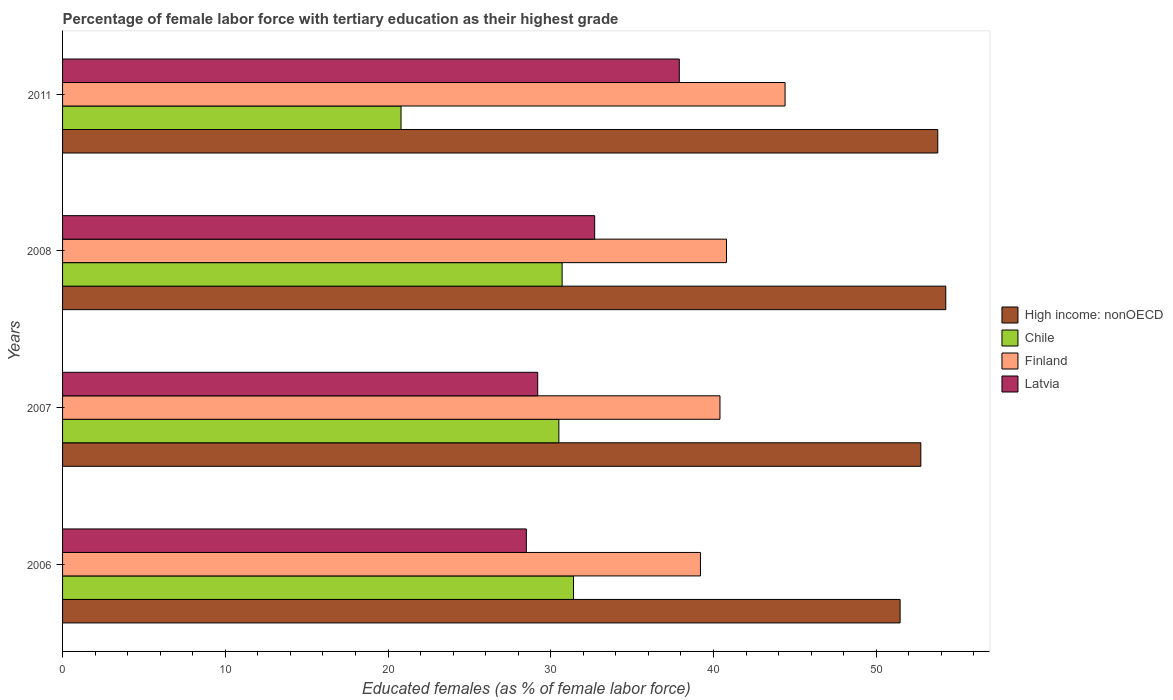Are the number of bars on each tick of the Y-axis equal?
Your answer should be compact. Yes. What is the percentage of female labor force with tertiary education in Latvia in 2008?
Your response must be concise. 32.7. Across all years, what is the maximum percentage of female labor force with tertiary education in High income: nonOECD?
Provide a short and direct response. 54.28. In which year was the percentage of female labor force with tertiary education in Finland minimum?
Ensure brevity in your answer.  2006. What is the total percentage of female labor force with tertiary education in High income: nonOECD in the graph?
Your answer should be very brief. 212.27. What is the difference between the percentage of female labor force with tertiary education in Chile in 2006 and that in 2008?
Offer a very short reply. 0.7. What is the difference between the percentage of female labor force with tertiary education in Latvia in 2006 and the percentage of female labor force with tertiary education in Finland in 2011?
Keep it short and to the point. -15.9. What is the average percentage of female labor force with tertiary education in High income: nonOECD per year?
Your response must be concise. 53.07. In the year 2008, what is the difference between the percentage of female labor force with tertiary education in High income: nonOECD and percentage of female labor force with tertiary education in Finland?
Offer a terse response. 13.48. In how many years, is the percentage of female labor force with tertiary education in Finland greater than 42 %?
Give a very brief answer. 1. What is the ratio of the percentage of female labor force with tertiary education in Finland in 2006 to that in 2008?
Your answer should be compact. 0.96. What is the difference between the highest and the second highest percentage of female labor force with tertiary education in High income: nonOECD?
Your answer should be very brief. 0.49. What is the difference between the highest and the lowest percentage of female labor force with tertiary education in Chile?
Offer a terse response. 10.6. In how many years, is the percentage of female labor force with tertiary education in Chile greater than the average percentage of female labor force with tertiary education in Chile taken over all years?
Give a very brief answer. 3. Is the sum of the percentage of female labor force with tertiary education in Latvia in 2007 and 2008 greater than the maximum percentage of female labor force with tertiary education in Chile across all years?
Provide a short and direct response. Yes. Is it the case that in every year, the sum of the percentage of female labor force with tertiary education in Chile and percentage of female labor force with tertiary education in Finland is greater than the sum of percentage of female labor force with tertiary education in High income: nonOECD and percentage of female labor force with tertiary education in Latvia?
Offer a very short reply. No. What does the 4th bar from the top in 2006 represents?
Make the answer very short. High income: nonOECD. What does the 3rd bar from the bottom in 2007 represents?
Your response must be concise. Finland. Are all the bars in the graph horizontal?
Ensure brevity in your answer.  Yes. Does the graph contain any zero values?
Provide a short and direct response. No. How many legend labels are there?
Your response must be concise. 4. What is the title of the graph?
Your response must be concise. Percentage of female labor force with tertiary education as their highest grade. Does "Madagascar" appear as one of the legend labels in the graph?
Your response must be concise. No. What is the label or title of the X-axis?
Ensure brevity in your answer.  Educated females (as % of female labor force). What is the Educated females (as % of female labor force) in High income: nonOECD in 2006?
Make the answer very short. 51.47. What is the Educated females (as % of female labor force) of Chile in 2006?
Your response must be concise. 31.4. What is the Educated females (as % of female labor force) of Finland in 2006?
Your response must be concise. 39.2. What is the Educated females (as % of female labor force) of High income: nonOECD in 2007?
Provide a short and direct response. 52.74. What is the Educated females (as % of female labor force) in Chile in 2007?
Ensure brevity in your answer.  30.5. What is the Educated females (as % of female labor force) in Finland in 2007?
Your response must be concise. 40.4. What is the Educated females (as % of female labor force) in Latvia in 2007?
Provide a succinct answer. 29.2. What is the Educated females (as % of female labor force) in High income: nonOECD in 2008?
Offer a very short reply. 54.28. What is the Educated females (as % of female labor force) of Chile in 2008?
Give a very brief answer. 30.7. What is the Educated females (as % of female labor force) in Finland in 2008?
Provide a succinct answer. 40.8. What is the Educated females (as % of female labor force) of Latvia in 2008?
Make the answer very short. 32.7. What is the Educated females (as % of female labor force) in High income: nonOECD in 2011?
Give a very brief answer. 53.78. What is the Educated females (as % of female labor force) in Chile in 2011?
Provide a succinct answer. 20.8. What is the Educated females (as % of female labor force) in Finland in 2011?
Offer a terse response. 44.4. What is the Educated females (as % of female labor force) in Latvia in 2011?
Make the answer very short. 37.9. Across all years, what is the maximum Educated females (as % of female labor force) of High income: nonOECD?
Your answer should be compact. 54.28. Across all years, what is the maximum Educated females (as % of female labor force) of Chile?
Your answer should be very brief. 31.4. Across all years, what is the maximum Educated females (as % of female labor force) of Finland?
Keep it short and to the point. 44.4. Across all years, what is the maximum Educated females (as % of female labor force) in Latvia?
Your answer should be compact. 37.9. Across all years, what is the minimum Educated females (as % of female labor force) in High income: nonOECD?
Keep it short and to the point. 51.47. Across all years, what is the minimum Educated females (as % of female labor force) in Chile?
Your response must be concise. 20.8. Across all years, what is the minimum Educated females (as % of female labor force) of Finland?
Ensure brevity in your answer.  39.2. What is the total Educated females (as % of female labor force) of High income: nonOECD in the graph?
Your response must be concise. 212.27. What is the total Educated females (as % of female labor force) in Chile in the graph?
Ensure brevity in your answer.  113.4. What is the total Educated females (as % of female labor force) of Finland in the graph?
Provide a succinct answer. 164.8. What is the total Educated females (as % of female labor force) of Latvia in the graph?
Give a very brief answer. 128.3. What is the difference between the Educated females (as % of female labor force) of High income: nonOECD in 2006 and that in 2007?
Provide a succinct answer. -1.27. What is the difference between the Educated females (as % of female labor force) in Chile in 2006 and that in 2007?
Provide a short and direct response. 0.9. What is the difference between the Educated females (as % of female labor force) of Finland in 2006 and that in 2007?
Give a very brief answer. -1.2. What is the difference between the Educated females (as % of female labor force) in High income: nonOECD in 2006 and that in 2008?
Offer a terse response. -2.81. What is the difference between the Educated females (as % of female labor force) of Chile in 2006 and that in 2008?
Provide a short and direct response. 0.7. What is the difference between the Educated females (as % of female labor force) in Latvia in 2006 and that in 2008?
Offer a very short reply. -4.2. What is the difference between the Educated females (as % of female labor force) of High income: nonOECD in 2006 and that in 2011?
Give a very brief answer. -2.31. What is the difference between the Educated females (as % of female labor force) in Chile in 2006 and that in 2011?
Your answer should be very brief. 10.6. What is the difference between the Educated females (as % of female labor force) in Latvia in 2006 and that in 2011?
Provide a succinct answer. -9.4. What is the difference between the Educated females (as % of female labor force) of High income: nonOECD in 2007 and that in 2008?
Your answer should be very brief. -1.53. What is the difference between the Educated females (as % of female labor force) of Chile in 2007 and that in 2008?
Keep it short and to the point. -0.2. What is the difference between the Educated females (as % of female labor force) of Finland in 2007 and that in 2008?
Keep it short and to the point. -0.4. What is the difference between the Educated females (as % of female labor force) of Latvia in 2007 and that in 2008?
Ensure brevity in your answer.  -3.5. What is the difference between the Educated females (as % of female labor force) of High income: nonOECD in 2007 and that in 2011?
Your response must be concise. -1.04. What is the difference between the Educated females (as % of female labor force) in Latvia in 2007 and that in 2011?
Provide a succinct answer. -8.7. What is the difference between the Educated females (as % of female labor force) of High income: nonOECD in 2008 and that in 2011?
Offer a very short reply. 0.49. What is the difference between the Educated females (as % of female labor force) of Chile in 2008 and that in 2011?
Your answer should be very brief. 9.9. What is the difference between the Educated females (as % of female labor force) in Finland in 2008 and that in 2011?
Provide a succinct answer. -3.6. What is the difference between the Educated females (as % of female labor force) in High income: nonOECD in 2006 and the Educated females (as % of female labor force) in Chile in 2007?
Provide a short and direct response. 20.97. What is the difference between the Educated females (as % of female labor force) of High income: nonOECD in 2006 and the Educated females (as % of female labor force) of Finland in 2007?
Provide a succinct answer. 11.07. What is the difference between the Educated females (as % of female labor force) of High income: nonOECD in 2006 and the Educated females (as % of female labor force) of Latvia in 2007?
Offer a very short reply. 22.27. What is the difference between the Educated females (as % of female labor force) in Chile in 2006 and the Educated females (as % of female labor force) in Finland in 2007?
Ensure brevity in your answer.  -9. What is the difference between the Educated females (as % of female labor force) of Chile in 2006 and the Educated females (as % of female labor force) of Latvia in 2007?
Your answer should be very brief. 2.2. What is the difference between the Educated females (as % of female labor force) of Finland in 2006 and the Educated females (as % of female labor force) of Latvia in 2007?
Ensure brevity in your answer.  10. What is the difference between the Educated females (as % of female labor force) of High income: nonOECD in 2006 and the Educated females (as % of female labor force) of Chile in 2008?
Ensure brevity in your answer.  20.77. What is the difference between the Educated females (as % of female labor force) in High income: nonOECD in 2006 and the Educated females (as % of female labor force) in Finland in 2008?
Your response must be concise. 10.67. What is the difference between the Educated females (as % of female labor force) of High income: nonOECD in 2006 and the Educated females (as % of female labor force) of Latvia in 2008?
Your answer should be very brief. 18.77. What is the difference between the Educated females (as % of female labor force) of Chile in 2006 and the Educated females (as % of female labor force) of Finland in 2008?
Provide a short and direct response. -9.4. What is the difference between the Educated females (as % of female labor force) of Chile in 2006 and the Educated females (as % of female labor force) of Latvia in 2008?
Offer a terse response. -1.3. What is the difference between the Educated females (as % of female labor force) of Finland in 2006 and the Educated females (as % of female labor force) of Latvia in 2008?
Provide a short and direct response. 6.5. What is the difference between the Educated females (as % of female labor force) of High income: nonOECD in 2006 and the Educated females (as % of female labor force) of Chile in 2011?
Provide a short and direct response. 30.67. What is the difference between the Educated females (as % of female labor force) of High income: nonOECD in 2006 and the Educated females (as % of female labor force) of Finland in 2011?
Offer a terse response. 7.07. What is the difference between the Educated females (as % of female labor force) in High income: nonOECD in 2006 and the Educated females (as % of female labor force) in Latvia in 2011?
Give a very brief answer. 13.57. What is the difference between the Educated females (as % of female labor force) of Chile in 2006 and the Educated females (as % of female labor force) of Finland in 2011?
Provide a short and direct response. -13. What is the difference between the Educated females (as % of female labor force) in High income: nonOECD in 2007 and the Educated females (as % of female labor force) in Chile in 2008?
Keep it short and to the point. 22.04. What is the difference between the Educated females (as % of female labor force) of High income: nonOECD in 2007 and the Educated females (as % of female labor force) of Finland in 2008?
Offer a very short reply. 11.94. What is the difference between the Educated females (as % of female labor force) of High income: nonOECD in 2007 and the Educated females (as % of female labor force) of Latvia in 2008?
Offer a terse response. 20.04. What is the difference between the Educated females (as % of female labor force) of Chile in 2007 and the Educated females (as % of female labor force) of Finland in 2008?
Your answer should be compact. -10.3. What is the difference between the Educated females (as % of female labor force) in Finland in 2007 and the Educated females (as % of female labor force) in Latvia in 2008?
Provide a short and direct response. 7.7. What is the difference between the Educated females (as % of female labor force) in High income: nonOECD in 2007 and the Educated females (as % of female labor force) in Chile in 2011?
Provide a succinct answer. 31.94. What is the difference between the Educated females (as % of female labor force) of High income: nonOECD in 2007 and the Educated females (as % of female labor force) of Finland in 2011?
Provide a short and direct response. 8.34. What is the difference between the Educated females (as % of female labor force) in High income: nonOECD in 2007 and the Educated females (as % of female labor force) in Latvia in 2011?
Ensure brevity in your answer.  14.84. What is the difference between the Educated females (as % of female labor force) in Finland in 2007 and the Educated females (as % of female labor force) in Latvia in 2011?
Your answer should be compact. 2.5. What is the difference between the Educated females (as % of female labor force) of High income: nonOECD in 2008 and the Educated females (as % of female labor force) of Chile in 2011?
Offer a very short reply. 33.48. What is the difference between the Educated females (as % of female labor force) of High income: nonOECD in 2008 and the Educated females (as % of female labor force) of Finland in 2011?
Your response must be concise. 9.88. What is the difference between the Educated females (as % of female labor force) of High income: nonOECD in 2008 and the Educated females (as % of female labor force) of Latvia in 2011?
Make the answer very short. 16.38. What is the difference between the Educated females (as % of female labor force) in Chile in 2008 and the Educated females (as % of female labor force) in Finland in 2011?
Offer a very short reply. -13.7. What is the difference between the Educated females (as % of female labor force) in Finland in 2008 and the Educated females (as % of female labor force) in Latvia in 2011?
Your response must be concise. 2.9. What is the average Educated females (as % of female labor force) of High income: nonOECD per year?
Give a very brief answer. 53.07. What is the average Educated females (as % of female labor force) of Chile per year?
Offer a terse response. 28.35. What is the average Educated females (as % of female labor force) in Finland per year?
Make the answer very short. 41.2. What is the average Educated females (as % of female labor force) of Latvia per year?
Your answer should be very brief. 32.08. In the year 2006, what is the difference between the Educated females (as % of female labor force) of High income: nonOECD and Educated females (as % of female labor force) of Chile?
Your answer should be very brief. 20.07. In the year 2006, what is the difference between the Educated females (as % of female labor force) in High income: nonOECD and Educated females (as % of female labor force) in Finland?
Offer a very short reply. 12.27. In the year 2006, what is the difference between the Educated females (as % of female labor force) in High income: nonOECD and Educated females (as % of female labor force) in Latvia?
Make the answer very short. 22.97. In the year 2006, what is the difference between the Educated females (as % of female labor force) of Finland and Educated females (as % of female labor force) of Latvia?
Provide a short and direct response. 10.7. In the year 2007, what is the difference between the Educated females (as % of female labor force) in High income: nonOECD and Educated females (as % of female labor force) in Chile?
Provide a succinct answer. 22.24. In the year 2007, what is the difference between the Educated females (as % of female labor force) in High income: nonOECD and Educated females (as % of female labor force) in Finland?
Provide a short and direct response. 12.34. In the year 2007, what is the difference between the Educated females (as % of female labor force) of High income: nonOECD and Educated females (as % of female labor force) of Latvia?
Provide a short and direct response. 23.54. In the year 2007, what is the difference between the Educated females (as % of female labor force) in Chile and Educated females (as % of female labor force) in Latvia?
Provide a succinct answer. 1.3. In the year 2007, what is the difference between the Educated females (as % of female labor force) of Finland and Educated females (as % of female labor force) of Latvia?
Offer a very short reply. 11.2. In the year 2008, what is the difference between the Educated females (as % of female labor force) in High income: nonOECD and Educated females (as % of female labor force) in Chile?
Offer a very short reply. 23.58. In the year 2008, what is the difference between the Educated females (as % of female labor force) of High income: nonOECD and Educated females (as % of female labor force) of Finland?
Offer a terse response. 13.48. In the year 2008, what is the difference between the Educated females (as % of female labor force) in High income: nonOECD and Educated females (as % of female labor force) in Latvia?
Provide a short and direct response. 21.58. In the year 2008, what is the difference between the Educated females (as % of female labor force) of Chile and Educated females (as % of female labor force) of Latvia?
Keep it short and to the point. -2. In the year 2011, what is the difference between the Educated females (as % of female labor force) in High income: nonOECD and Educated females (as % of female labor force) in Chile?
Your answer should be compact. 32.98. In the year 2011, what is the difference between the Educated females (as % of female labor force) in High income: nonOECD and Educated females (as % of female labor force) in Finland?
Your response must be concise. 9.38. In the year 2011, what is the difference between the Educated females (as % of female labor force) in High income: nonOECD and Educated females (as % of female labor force) in Latvia?
Your answer should be very brief. 15.88. In the year 2011, what is the difference between the Educated females (as % of female labor force) of Chile and Educated females (as % of female labor force) of Finland?
Make the answer very short. -23.6. In the year 2011, what is the difference between the Educated females (as % of female labor force) in Chile and Educated females (as % of female labor force) in Latvia?
Provide a succinct answer. -17.1. In the year 2011, what is the difference between the Educated females (as % of female labor force) of Finland and Educated females (as % of female labor force) of Latvia?
Your answer should be very brief. 6.5. What is the ratio of the Educated females (as % of female labor force) of High income: nonOECD in 2006 to that in 2007?
Make the answer very short. 0.98. What is the ratio of the Educated females (as % of female labor force) of Chile in 2006 to that in 2007?
Provide a short and direct response. 1.03. What is the ratio of the Educated females (as % of female labor force) of Finland in 2006 to that in 2007?
Your answer should be very brief. 0.97. What is the ratio of the Educated females (as % of female labor force) in Latvia in 2006 to that in 2007?
Provide a succinct answer. 0.98. What is the ratio of the Educated females (as % of female labor force) of High income: nonOECD in 2006 to that in 2008?
Provide a succinct answer. 0.95. What is the ratio of the Educated females (as % of female labor force) of Chile in 2006 to that in 2008?
Offer a very short reply. 1.02. What is the ratio of the Educated females (as % of female labor force) of Finland in 2006 to that in 2008?
Your answer should be very brief. 0.96. What is the ratio of the Educated females (as % of female labor force) of Latvia in 2006 to that in 2008?
Provide a succinct answer. 0.87. What is the ratio of the Educated females (as % of female labor force) in Chile in 2006 to that in 2011?
Your answer should be compact. 1.51. What is the ratio of the Educated females (as % of female labor force) in Finland in 2006 to that in 2011?
Ensure brevity in your answer.  0.88. What is the ratio of the Educated females (as % of female labor force) of Latvia in 2006 to that in 2011?
Make the answer very short. 0.75. What is the ratio of the Educated females (as % of female labor force) of High income: nonOECD in 2007 to that in 2008?
Your response must be concise. 0.97. What is the ratio of the Educated females (as % of female labor force) in Finland in 2007 to that in 2008?
Make the answer very short. 0.99. What is the ratio of the Educated females (as % of female labor force) of Latvia in 2007 to that in 2008?
Provide a succinct answer. 0.89. What is the ratio of the Educated females (as % of female labor force) of High income: nonOECD in 2007 to that in 2011?
Your response must be concise. 0.98. What is the ratio of the Educated females (as % of female labor force) in Chile in 2007 to that in 2011?
Ensure brevity in your answer.  1.47. What is the ratio of the Educated females (as % of female labor force) of Finland in 2007 to that in 2011?
Offer a terse response. 0.91. What is the ratio of the Educated females (as % of female labor force) of Latvia in 2007 to that in 2011?
Your response must be concise. 0.77. What is the ratio of the Educated females (as % of female labor force) in High income: nonOECD in 2008 to that in 2011?
Offer a very short reply. 1.01. What is the ratio of the Educated females (as % of female labor force) in Chile in 2008 to that in 2011?
Give a very brief answer. 1.48. What is the ratio of the Educated females (as % of female labor force) of Finland in 2008 to that in 2011?
Provide a short and direct response. 0.92. What is the ratio of the Educated females (as % of female labor force) of Latvia in 2008 to that in 2011?
Provide a succinct answer. 0.86. What is the difference between the highest and the second highest Educated females (as % of female labor force) of High income: nonOECD?
Offer a terse response. 0.49. What is the difference between the highest and the second highest Educated females (as % of female labor force) in Chile?
Your answer should be compact. 0.7. What is the difference between the highest and the second highest Educated females (as % of female labor force) in Latvia?
Offer a very short reply. 5.2. What is the difference between the highest and the lowest Educated females (as % of female labor force) of High income: nonOECD?
Your response must be concise. 2.81. What is the difference between the highest and the lowest Educated females (as % of female labor force) of Chile?
Ensure brevity in your answer.  10.6. What is the difference between the highest and the lowest Educated females (as % of female labor force) of Latvia?
Your answer should be very brief. 9.4. 